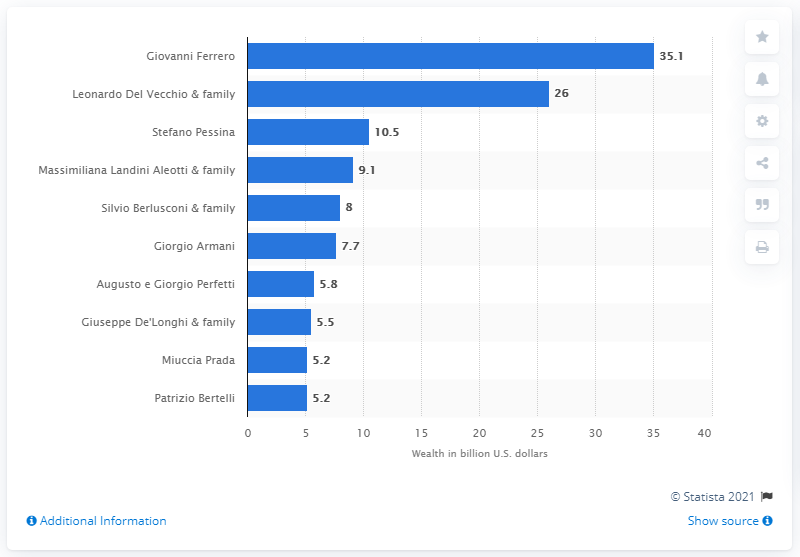Indicate a few pertinent items in this graphic. Giovanni Ferrero's net worth in US dollars was 35.1 million. Del Vecchio's fortune was estimated to be 26... 